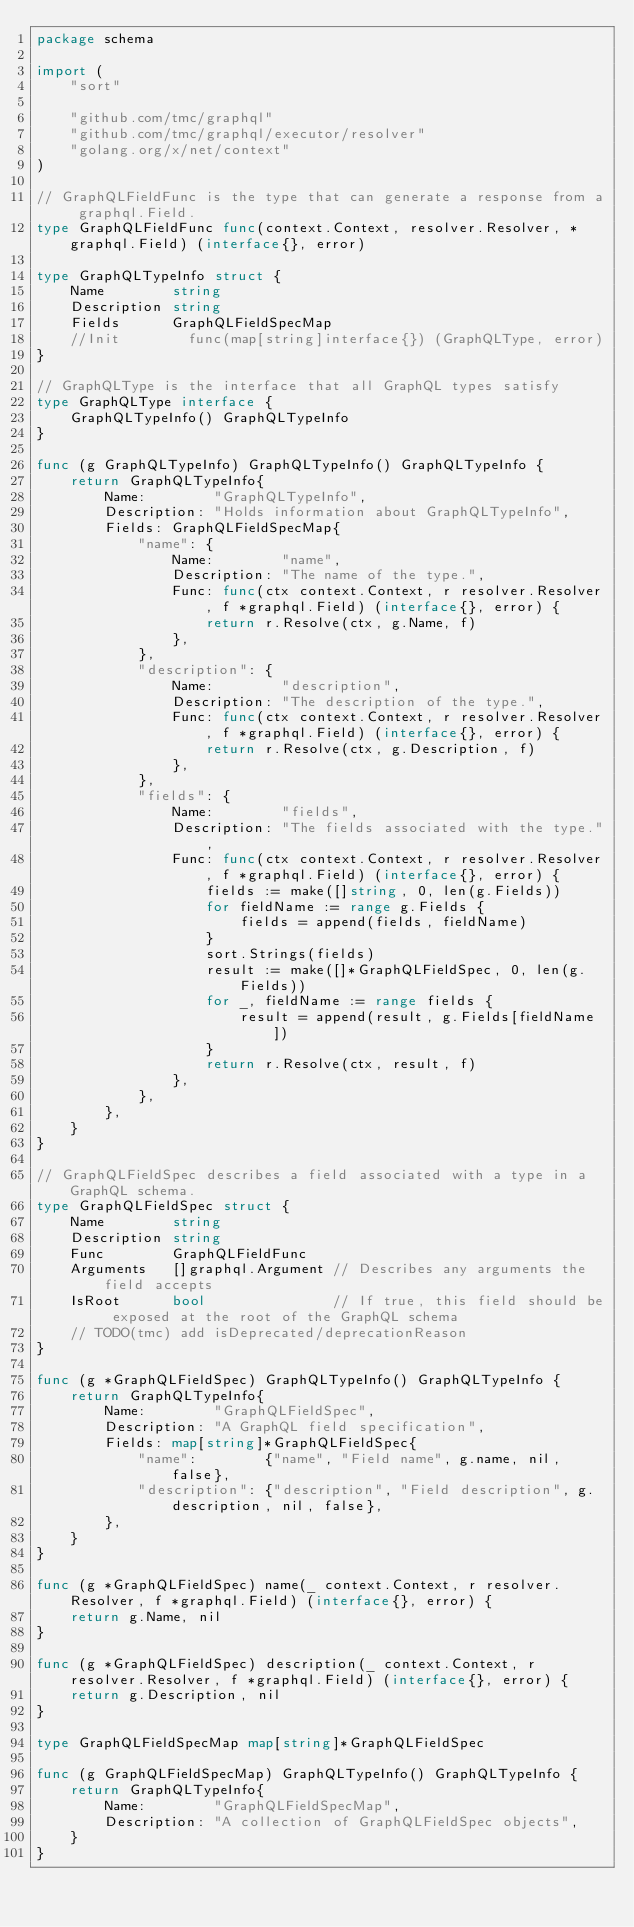Convert code to text. <code><loc_0><loc_0><loc_500><loc_500><_Go_>package schema

import (
	"sort"

	"github.com/tmc/graphql"
	"github.com/tmc/graphql/executor/resolver"
	"golang.org/x/net/context"
)

// GraphQLFieldFunc is the type that can generate a response from a graphql.Field.
type GraphQLFieldFunc func(context.Context, resolver.Resolver, *graphql.Field) (interface{}, error)

type GraphQLTypeInfo struct {
	Name        string
	Description string
	Fields      GraphQLFieldSpecMap
	//Init        func(map[string]interface{}) (GraphQLType, error)
}

// GraphQLType is the interface that all GraphQL types satisfy
type GraphQLType interface {
	GraphQLTypeInfo() GraphQLTypeInfo
}

func (g GraphQLTypeInfo) GraphQLTypeInfo() GraphQLTypeInfo {
	return GraphQLTypeInfo{
		Name:        "GraphQLTypeInfo",
		Description: "Holds information about GraphQLTypeInfo",
		Fields: GraphQLFieldSpecMap{
			"name": {
				Name:        "name",
				Description: "The name of the type.",
				Func: func(ctx context.Context, r resolver.Resolver, f *graphql.Field) (interface{}, error) {
					return r.Resolve(ctx, g.Name, f)
				},
			},
			"description": {
				Name:        "description",
				Description: "The description of the type.",
				Func: func(ctx context.Context, r resolver.Resolver, f *graphql.Field) (interface{}, error) {
					return r.Resolve(ctx, g.Description, f)
				},
			},
			"fields": {
				Name:        "fields",
				Description: "The fields associated with the type.",
				Func: func(ctx context.Context, r resolver.Resolver, f *graphql.Field) (interface{}, error) {
					fields := make([]string, 0, len(g.Fields))
					for fieldName := range g.Fields {
						fields = append(fields, fieldName)
					}
					sort.Strings(fields)
					result := make([]*GraphQLFieldSpec, 0, len(g.Fields))
					for _, fieldName := range fields {
						result = append(result, g.Fields[fieldName])
					}
					return r.Resolve(ctx, result, f)
				},
			},
		},
	}
}

// GraphQLFieldSpec describes a field associated with a type in a GraphQL schema.
type GraphQLFieldSpec struct {
	Name        string
	Description string
	Func        GraphQLFieldFunc
	Arguments   []graphql.Argument // Describes any arguments the field accepts
	IsRoot      bool               // If true, this field should be exposed at the root of the GraphQL schema
	// TODO(tmc) add isDeprecated/deprecationReason
}

func (g *GraphQLFieldSpec) GraphQLTypeInfo() GraphQLTypeInfo {
	return GraphQLTypeInfo{
		Name:        "GraphQLFieldSpec",
		Description: "A GraphQL field specification",
		Fields: map[string]*GraphQLFieldSpec{
			"name":        {"name", "Field name", g.name, nil, false},
			"description": {"description", "Field description", g.description, nil, false},
		},
	}
}

func (g *GraphQLFieldSpec) name(_ context.Context, r resolver.Resolver, f *graphql.Field) (interface{}, error) {
	return g.Name, nil
}

func (g *GraphQLFieldSpec) description(_ context.Context, r resolver.Resolver, f *graphql.Field) (interface{}, error) {
	return g.Description, nil
}

type GraphQLFieldSpecMap map[string]*GraphQLFieldSpec

func (g GraphQLFieldSpecMap) GraphQLTypeInfo() GraphQLTypeInfo {
	return GraphQLTypeInfo{
		Name:        "GraphQLFieldSpecMap",
		Description: "A collection of GraphQLFieldSpec objects",
	}
}
</code> 